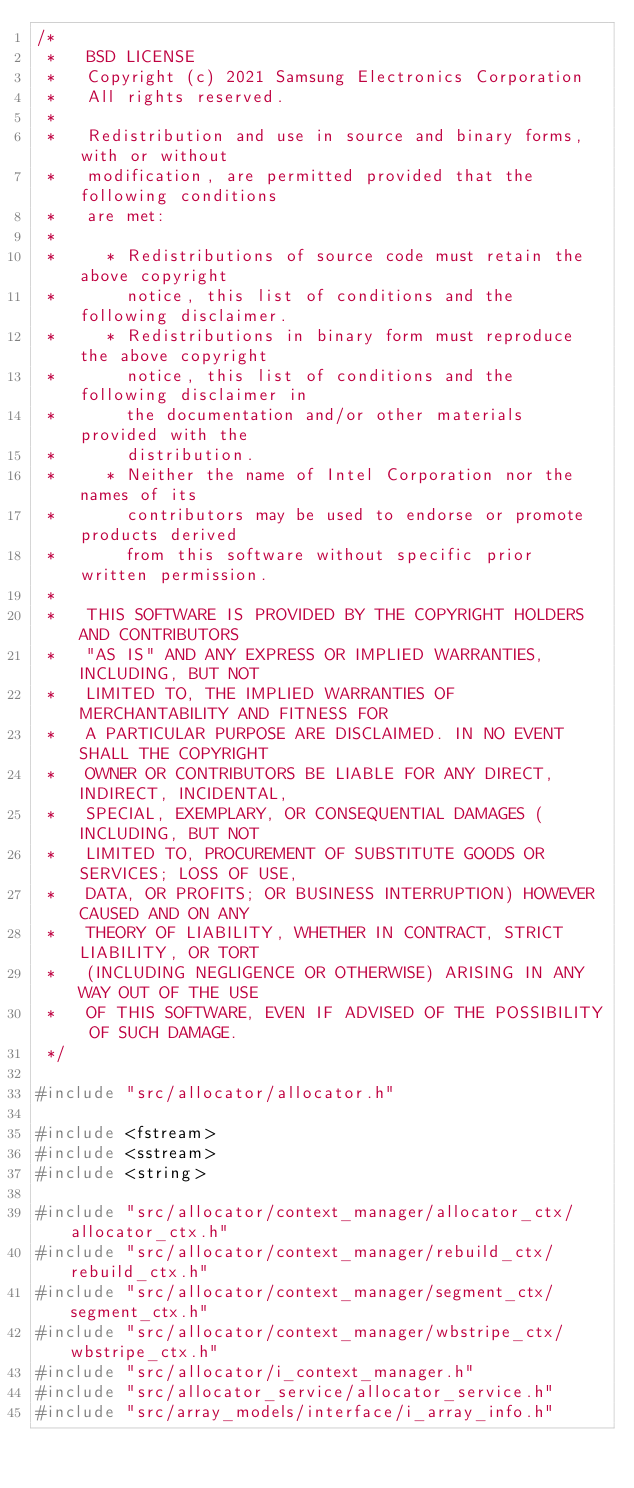<code> <loc_0><loc_0><loc_500><loc_500><_C++_>/*
 *   BSD LICENSE
 *   Copyright (c) 2021 Samsung Electronics Corporation
 *   All rights reserved.
 *
 *   Redistribution and use in source and binary forms, with or without
 *   modification, are permitted provided that the following conditions
 *   are met:
 *
 *     * Redistributions of source code must retain the above copyright
 *       notice, this list of conditions and the following disclaimer.
 *     * Redistributions in binary form must reproduce the above copyright
 *       notice, this list of conditions and the following disclaimer in
 *       the documentation and/or other materials provided with the
 *       distribution.
 *     * Neither the name of Intel Corporation nor the names of its
 *       contributors may be used to endorse or promote products derived
 *       from this software without specific prior written permission.
 *
 *   THIS SOFTWARE IS PROVIDED BY THE COPYRIGHT HOLDERS AND CONTRIBUTORS
 *   "AS IS" AND ANY EXPRESS OR IMPLIED WARRANTIES, INCLUDING, BUT NOT
 *   LIMITED TO, THE IMPLIED WARRANTIES OF MERCHANTABILITY AND FITNESS FOR
 *   A PARTICULAR PURPOSE ARE DISCLAIMED. IN NO EVENT SHALL THE COPYRIGHT
 *   OWNER OR CONTRIBUTORS BE LIABLE FOR ANY DIRECT, INDIRECT, INCIDENTAL,
 *   SPECIAL, EXEMPLARY, OR CONSEQUENTIAL DAMAGES (INCLUDING, BUT NOT
 *   LIMITED TO, PROCUREMENT OF SUBSTITUTE GOODS OR SERVICES; LOSS OF USE,
 *   DATA, OR PROFITS; OR BUSINESS INTERRUPTION) HOWEVER CAUSED AND ON ANY
 *   THEORY OF LIABILITY, WHETHER IN CONTRACT, STRICT LIABILITY, OR TORT
 *   (INCLUDING NEGLIGENCE OR OTHERWISE) ARISING IN ANY WAY OUT OF THE USE
 *   OF THIS SOFTWARE, EVEN IF ADVISED OF THE POSSIBILITY OF SUCH DAMAGE.
 */

#include "src/allocator/allocator.h"

#include <fstream>
#include <sstream>
#include <string>

#include "src/allocator/context_manager/allocator_ctx/allocator_ctx.h"
#include "src/allocator/context_manager/rebuild_ctx/rebuild_ctx.h"
#include "src/allocator/context_manager/segment_ctx/segment_ctx.h"
#include "src/allocator/context_manager/wbstripe_ctx/wbstripe_ctx.h"
#include "src/allocator/i_context_manager.h"
#include "src/allocator_service/allocator_service.h"
#include "src/array_models/interface/i_array_info.h"</code> 